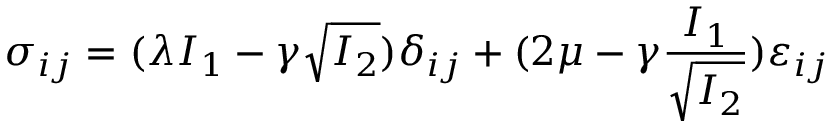<formula> <loc_0><loc_0><loc_500><loc_500>\sigma _ { i j } = ( \lambda I _ { 1 } - \gamma \sqrt { I _ { 2 } } ) \delta _ { i j } + ( 2 \mu - \gamma \frac { I _ { 1 } } { \sqrt { I _ { 2 } } } ) \varepsilon _ { i j }</formula> 